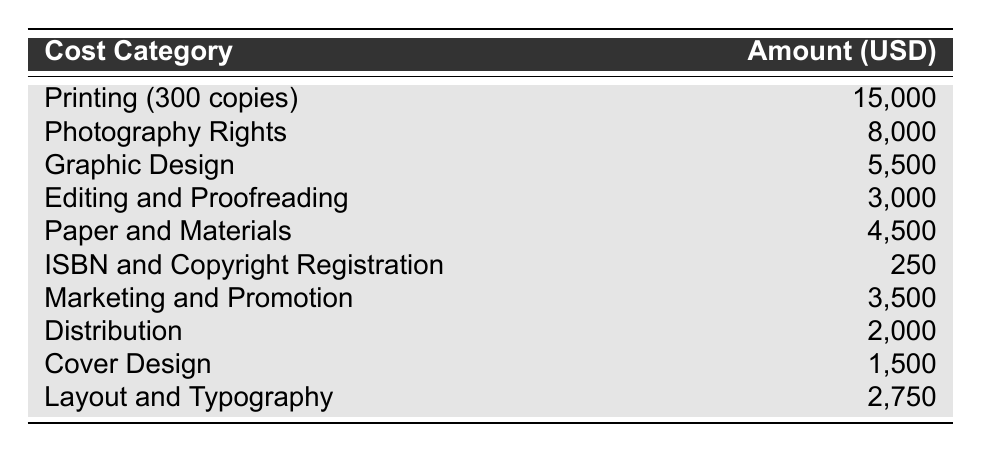What is the total cost for Photography Rights? The table shows the breakdown of costs, and for the category "Photography Rights," the amount listed is 8,000 USD.
Answer: 8,000 USD What is the cost of Editing and Proofreading? According to the table, the "Editing and Proofreading" category has an amount of 3,000 USD.
Answer: 3,000 USD What is the combined cost of Graphic Design and Marketing and Promotion? To find the combined cost, we add the amounts from both categories: Graphic Design (5,500 USD) + Marketing and Promotion (3,500 USD) = 9,000 USD.
Answer: 9,000 USD Is the cost of ISBN and Copyright Registration less than 300 USD? The table lists the cost of ISBN and Copyright Registration as 250 USD, which is indeed less than 300 USD.
Answer: Yes What is the total cost of all listed categories? We sum all the category amounts: 15,000 + 8,000 + 5,500 + 3,000 + 4,500 + 250 + 3,500 + 2,000 + 1,500 + 2,750 = 45,000 USD.
Answer: 45,000 USD Which cost category has the lowest amount? By examining the table, the category "ISBN and Copyright Registration" has the lowest amount of 250 USD.
Answer: ISBN and Copyright Registration What percentage of the total cost is allocated to Distribution? First, we found the total cost is 45,000 USD. The amount for Distribution is 2,000 USD. The percentage is calculated as (2,000 / 45,000) * 100 = 4.44%.
Answer: 4.44% Is the cost of Paper and Materials more than the combined costs of Cover Design and Layout and Typography? The cost for Paper and Materials is 4,500 USD. Cover Design is 1,500 USD and Layout and Typography is 2,750 USD. Adding these gives us 1,500 + 2,750 = 4,250 USD, which is less than 4,500 USD.
Answer: Yes What is the average cost of the top three highest expenses? The top three highest expenses are Printing (15,000 USD), Photography Rights (8,000 USD), and Graphic Design (5,500 USD). Their total is 15,000 + 8,000 + 5,500 = 28,500 USD. The average is calculated as 28,500 / 3 = 9,500 USD.
Answer: 9,500 USD 